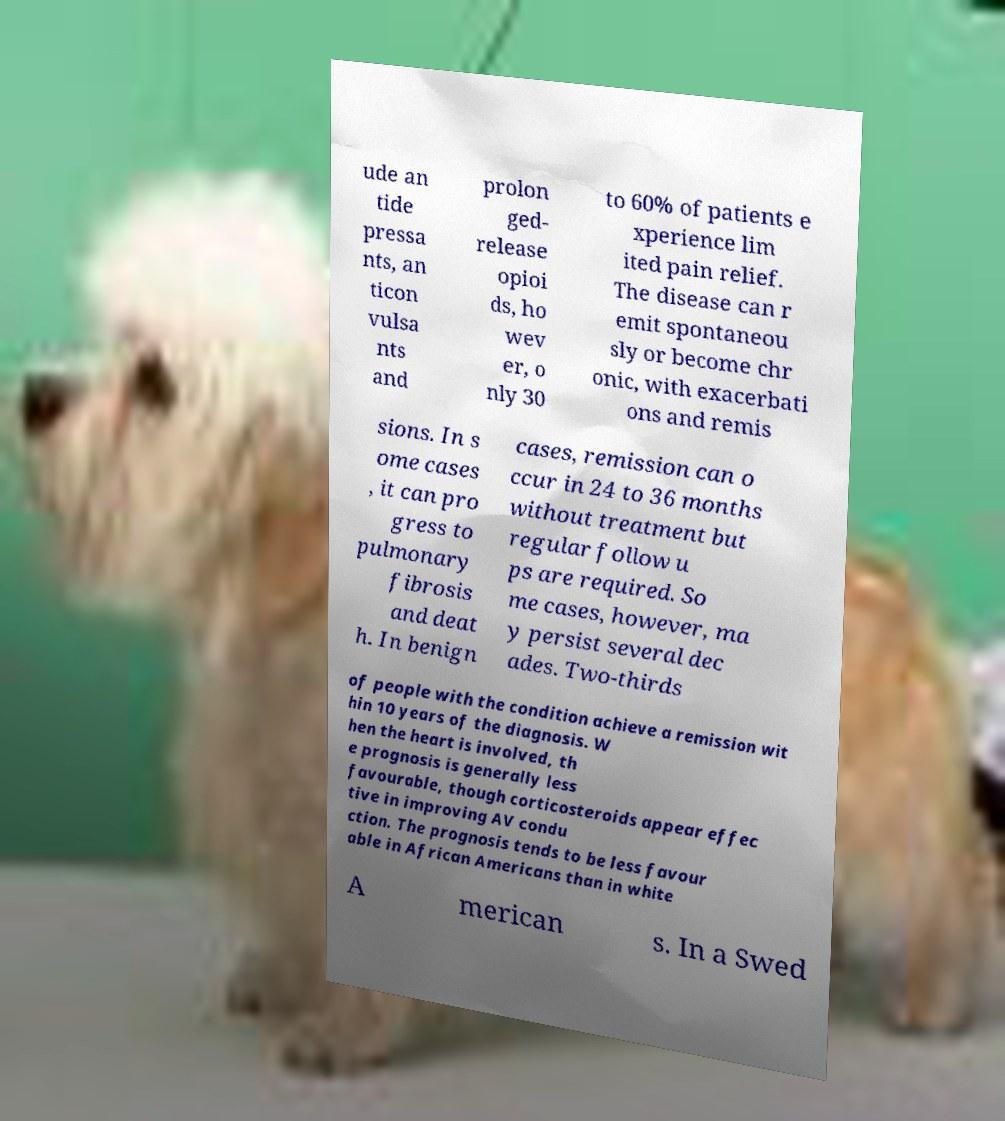There's text embedded in this image that I need extracted. Can you transcribe it verbatim? ude an tide pressa nts, an ticon vulsa nts and prolon ged- release opioi ds, ho wev er, o nly 30 to 60% of patients e xperience lim ited pain relief. The disease can r emit spontaneou sly or become chr onic, with exacerbati ons and remis sions. In s ome cases , it can pro gress to pulmonary fibrosis and deat h. In benign cases, remission can o ccur in 24 to 36 months without treatment but regular follow u ps are required. So me cases, however, ma y persist several dec ades. Two-thirds of people with the condition achieve a remission wit hin 10 years of the diagnosis. W hen the heart is involved, th e prognosis is generally less favourable, though corticosteroids appear effec tive in improving AV condu ction. The prognosis tends to be less favour able in African Americans than in white A merican s. In a Swed 